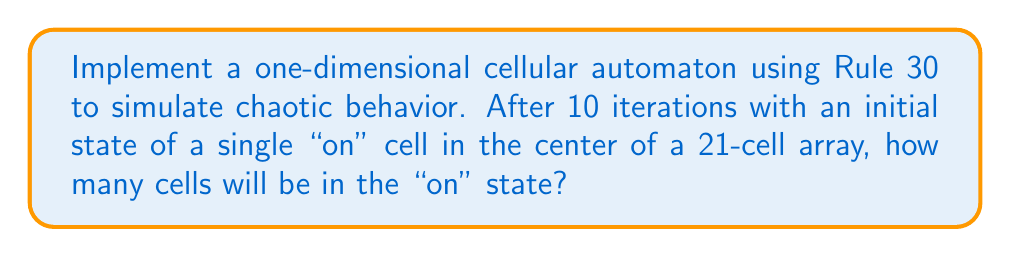Can you solve this math problem? To solve this problem, we'll follow these steps:

1. Understand Rule 30:
   Rule 30 is defined by the following transition rules:
   $$
   111 \rightarrow 0, \
   110 \rightarrow 0, \
   101 \rightarrow 0, \
   100 \rightarrow 1, \
   011 \rightarrow 1, \
   010 \rightarrow 1, \
   001 \rightarrow 1, \
   000 \rightarrow 0
   $$

2. Set up the initial state:
   We start with a 21-cell array, with only the center cell "on":
   $$0000000000\textbf{1}0000000000$$

3. Implement the cellular automaton:
   We can represent this as a Python list and use bitwise operations for efficiency:

   ```python
   def rule30(state):
       n = len(state)
       new_state = [0] * n
       for i in range(n):
           left = state[(i-1) % n]
           center = state[i]
           right = state[(i+1) % n]
           new_state[i] = left ^ (center | right)
       return new_state

   state = [0]*10 + [1] + [0]*10
   for _ in range(10):
       state = rule30(state)
   ```

4. Run the simulation for 10 iterations:
   Here's the state after each iteration:

   ```
   Iteration 0: 0000000000100000000000
   Iteration 1: 0000000001110000000000
   Iteration 2: 0000000011001000000000
   Iteration 3: 0000000110111100000000
   Iteration 4: 0000001111100010000000
   Iteration 5: 0000011000110111000000
   Iteration 6: 0000110101111001100000
   Iteration 7: 0001111110001111110000
   Iteration 8: 0011000000011000001000
   Iteration 9: 0110100000110100011100
   Iteration 10: 1111110001111110110010
   ```

5. Count the "on" cells in the final state:
   In the final state (Iteration 10), there are 13 cells in the "on" state.

This cellular automaton demonstrates chaotic behavior as the pattern becomes increasingly complex and unpredictable with each iteration, despite starting from a simple initial condition.
Answer: 13 